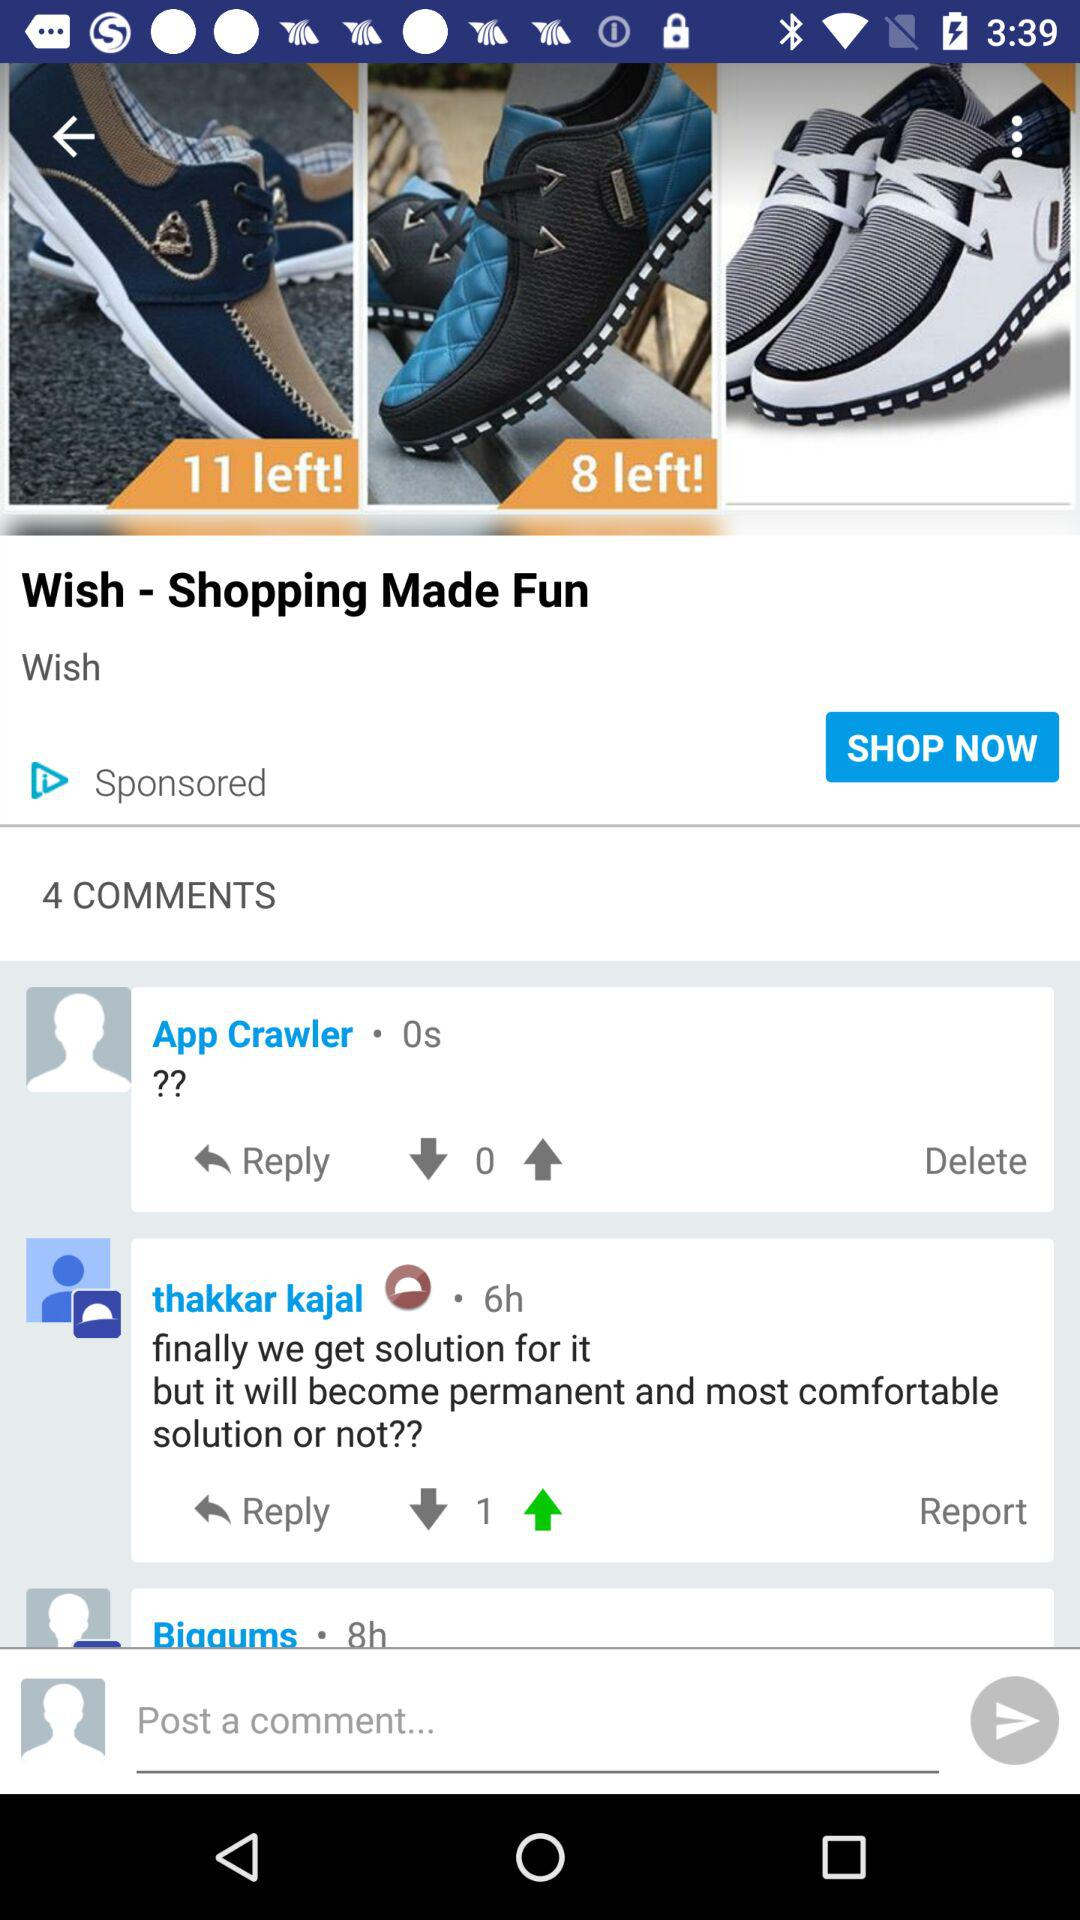Zero seconds ago, which user commented? Zero seconds ago, App Crawler commented. 